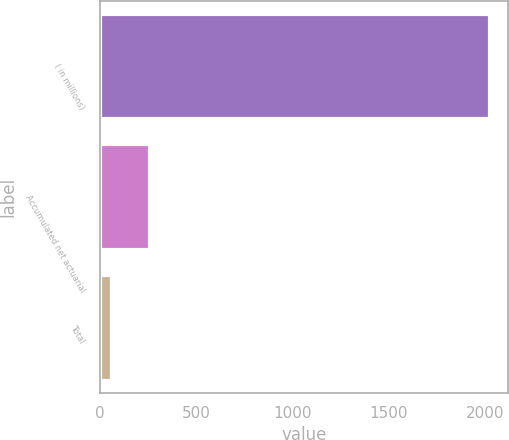<chart> <loc_0><loc_0><loc_500><loc_500><bar_chart><fcel>( in millions)<fcel>Accumulated net actuarial<fcel>Total<nl><fcel>2017<fcel>254.8<fcel>59<nl></chart> 